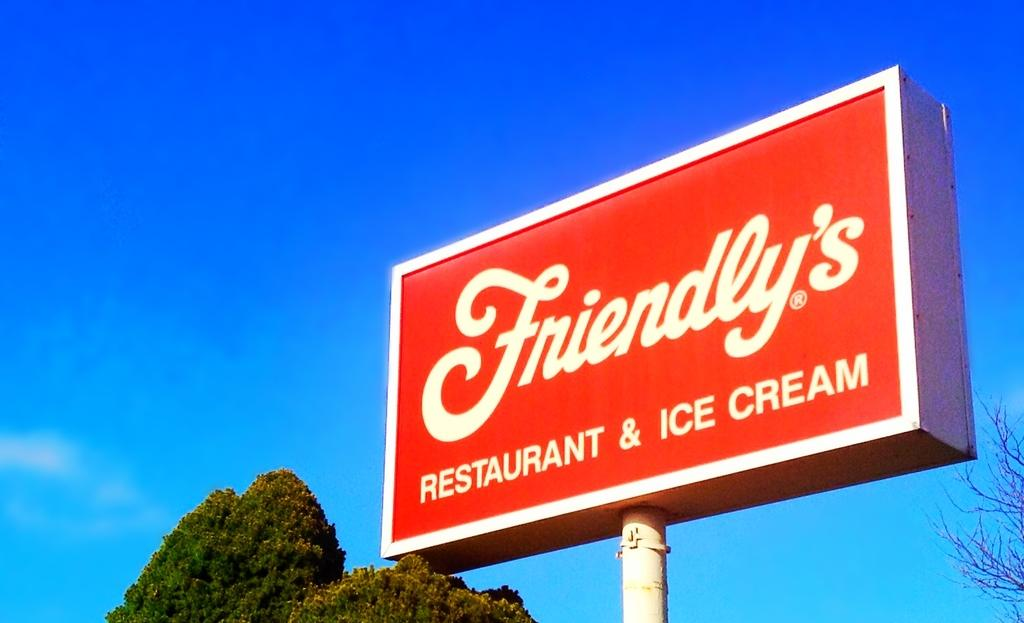<image>
Offer a succinct explanation of the picture presented. A large red sign for Friendly's restaurant against a blue sky. 